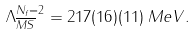Convert formula to latex. <formula><loc_0><loc_0><loc_500><loc_500>\Lambda _ { \overline { M S } } ^ { N _ { f } = 2 } = 2 1 7 ( 1 6 ) ( 1 1 ) \, M e V .</formula> 